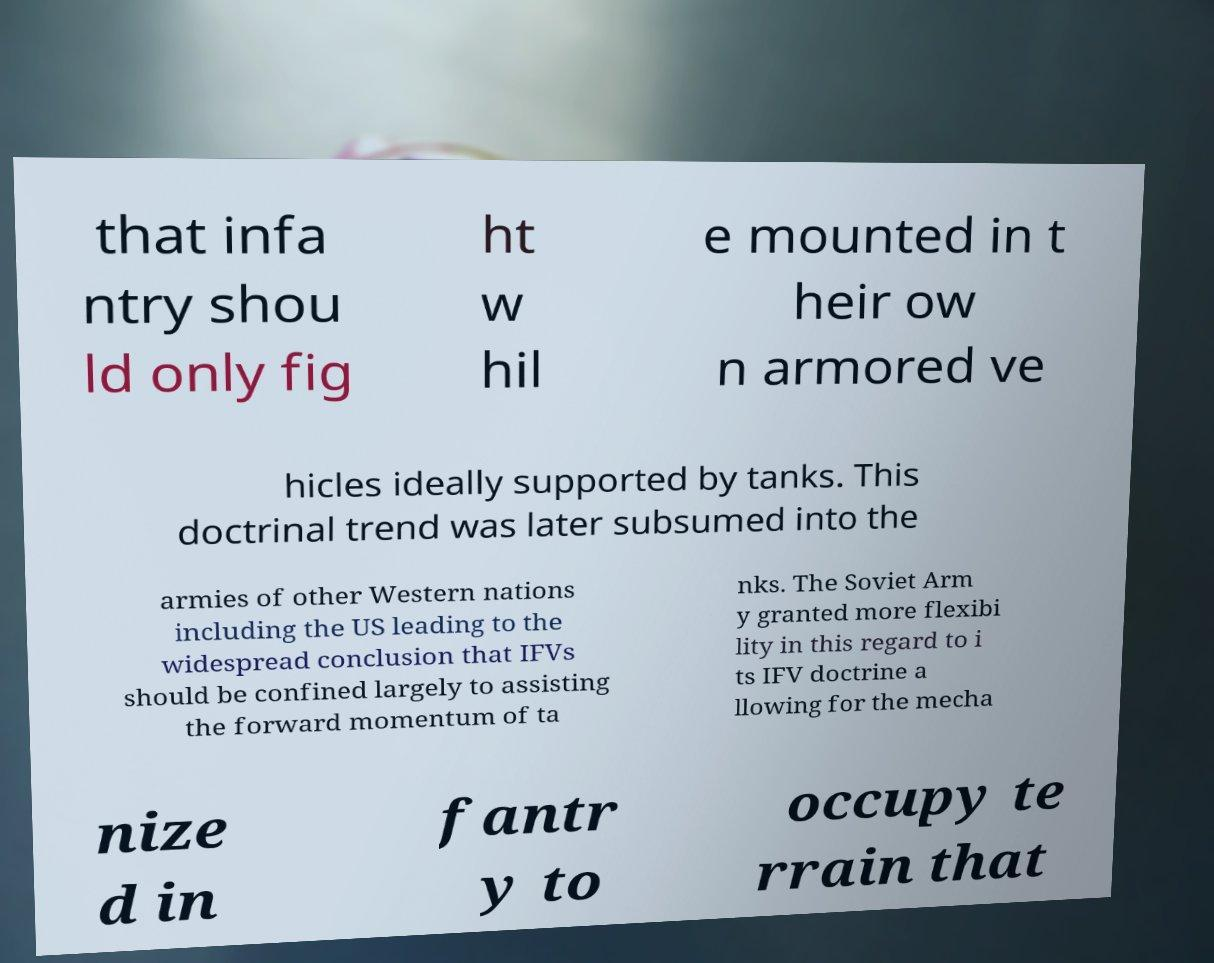Can you read and provide the text displayed in the image?This photo seems to have some interesting text. Can you extract and type it out for me? that infa ntry shou ld only fig ht w hil e mounted in t heir ow n armored ve hicles ideally supported by tanks. This doctrinal trend was later subsumed into the armies of other Western nations including the US leading to the widespread conclusion that IFVs should be confined largely to assisting the forward momentum of ta nks. The Soviet Arm y granted more flexibi lity in this regard to i ts IFV doctrine a llowing for the mecha nize d in fantr y to occupy te rrain that 